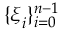Convert formula to latex. <formula><loc_0><loc_0><loc_500><loc_500>\{ \xi _ { i } \} _ { i = 0 } ^ { n - 1 }</formula> 